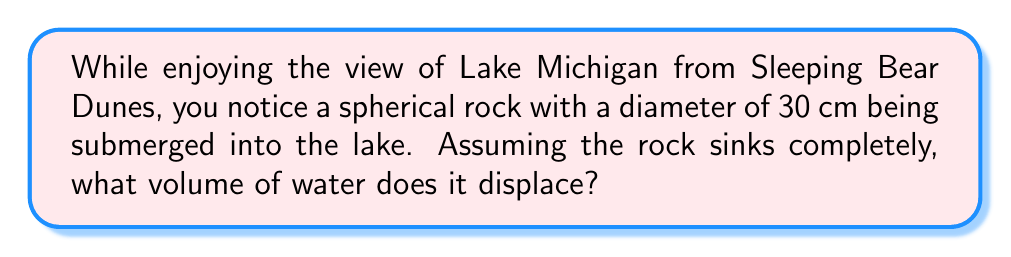Provide a solution to this math problem. To solve this problem, we need to follow these steps:

1. Recall the formula for the volume of a sphere:
   $$V = \frac{4}{3}\pi r^3$$
   where $r$ is the radius of the sphere.

2. Calculate the radius from the given diameter:
   Diameter = 30 cm
   $$r = \frac{30}{2} = 15 \text{ cm}$$

3. Substitute the radius into the volume formula:
   $$V = \frac{4}{3}\pi (15 \text{ cm})^3$$

4. Simplify:
   $$V = \frac{4}{3}\pi (3375 \text{ cm}^3)$$
   $$V = 4500\pi \text{ cm}^3$$

5. Calculate the final value (rounded to the nearest cm³):
   $$V \approx 14,137 \text{ cm}^3$$

According to Archimedes' principle, the volume of water displaced by a fully submerged object is equal to the volume of the object itself. Therefore, the rock displaces 14,137 cm³ of water from Lake Michigan.
Answer: 14,137 cm³ 